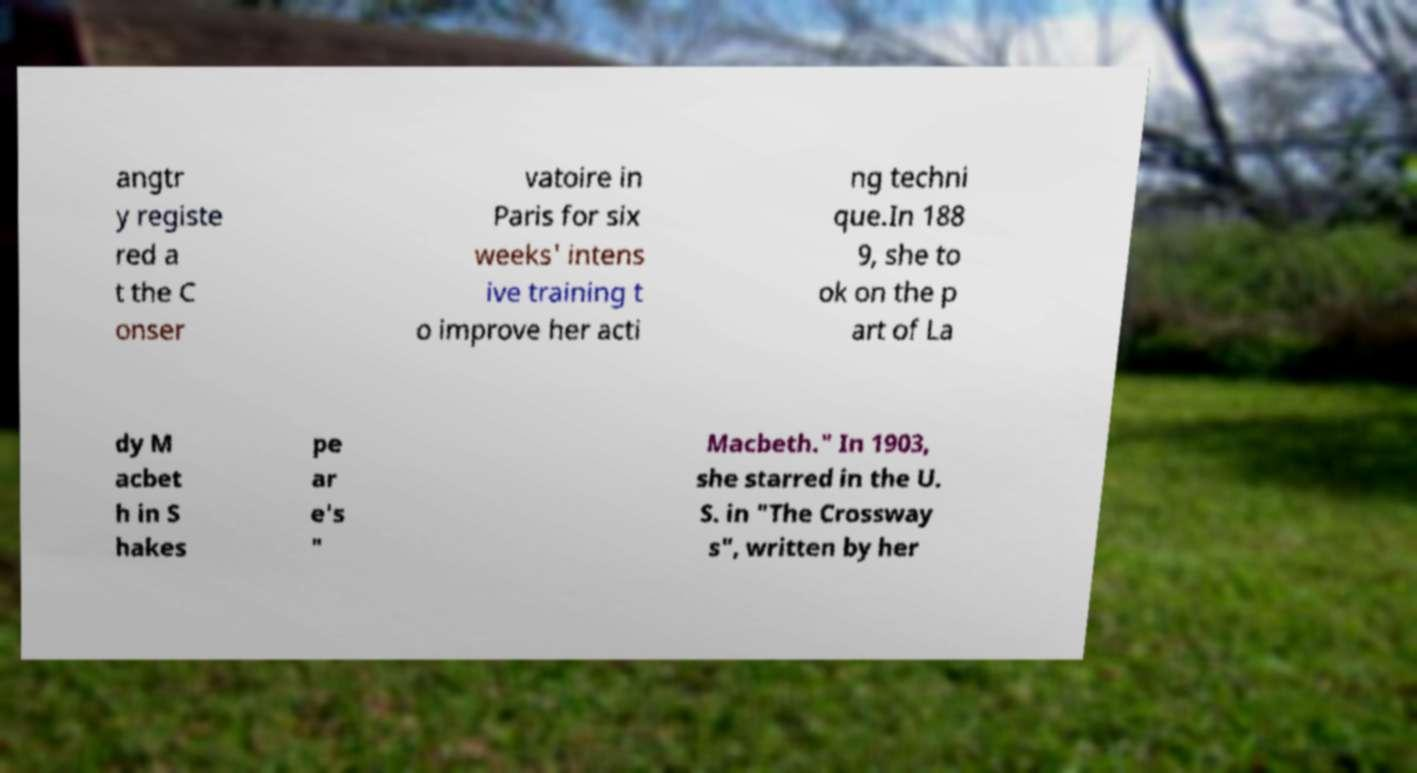What messages or text are displayed in this image? I need them in a readable, typed format. angtr y registe red a t the C onser vatoire in Paris for six weeks' intens ive training t o improve her acti ng techni que.In 188 9, she to ok on the p art of La dy M acbet h in S hakes pe ar e's " Macbeth." In 1903, she starred in the U. S. in "The Crossway s", written by her 